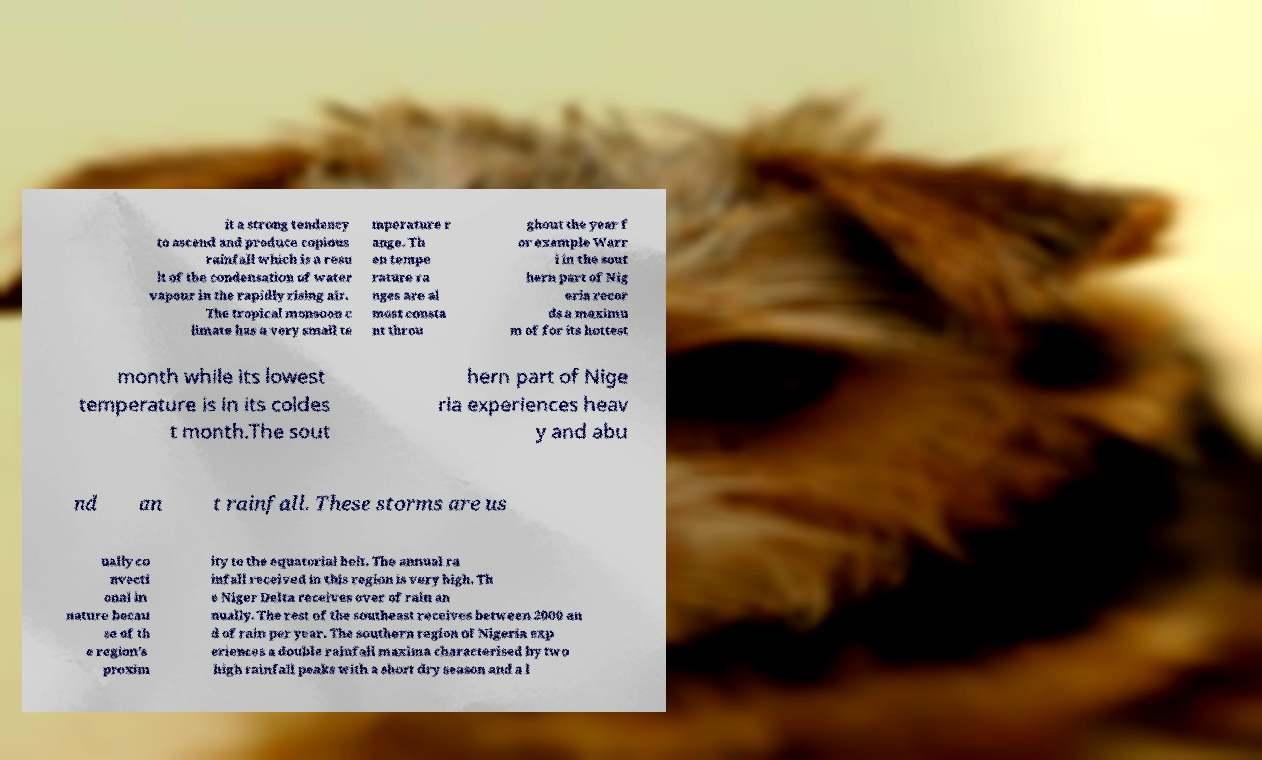Please identify and transcribe the text found in this image. it a strong tendency to ascend and produce copious rainfall which is a resu lt of the condensation of water vapour in the rapidly rising air. The tropical monsoon c limate has a very small te mperature r ange. Th en tempe rature ra nges are al most consta nt throu ghout the year f or example Warr i in the sout hern part of Nig eria recor ds a maximu m of for its hottest month while its lowest temperature is in its coldes t month.The sout hern part of Nige ria experiences heav y and abu nd an t rainfall. These storms are us ually co nvecti onal in nature becau se of th e region's proxim ity to the equatorial belt. The annual ra infall received in this region is very high. Th e Niger Delta receives over of rain an nually. The rest of the southeast receives between 2000 an d of rain per year. The southern region of Nigeria exp eriences a double rainfall maxima characterised by two high rainfall peaks with a short dry season and a l 